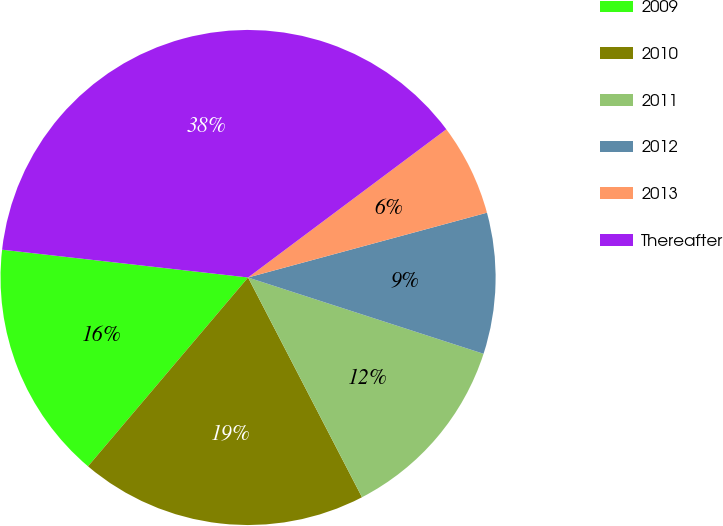Convert chart. <chart><loc_0><loc_0><loc_500><loc_500><pie_chart><fcel>2009<fcel>2010<fcel>2011<fcel>2012<fcel>2013<fcel>Thereafter<nl><fcel>15.6%<fcel>18.8%<fcel>12.4%<fcel>9.2%<fcel>6.0%<fcel>37.99%<nl></chart> 